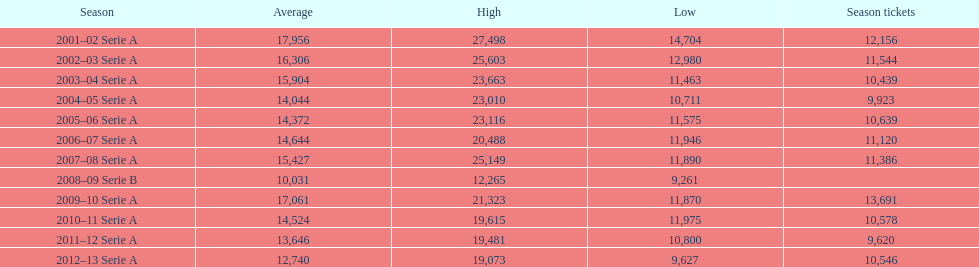How many seasons at the stadio ennio tardini had 11,000 or more seasonal passes? 5. 